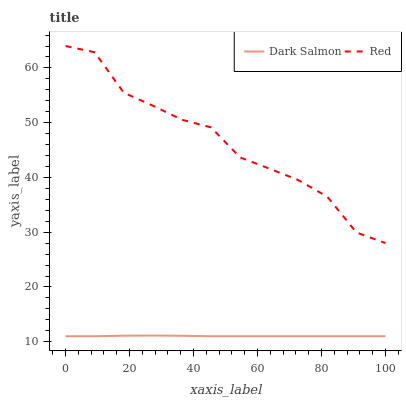Does Red have the minimum area under the curve?
Answer yes or no. No. Is Red the smoothest?
Answer yes or no. No. Does Red have the lowest value?
Answer yes or no. No. Is Dark Salmon less than Red?
Answer yes or no. Yes. Is Red greater than Dark Salmon?
Answer yes or no. Yes. Does Dark Salmon intersect Red?
Answer yes or no. No. 